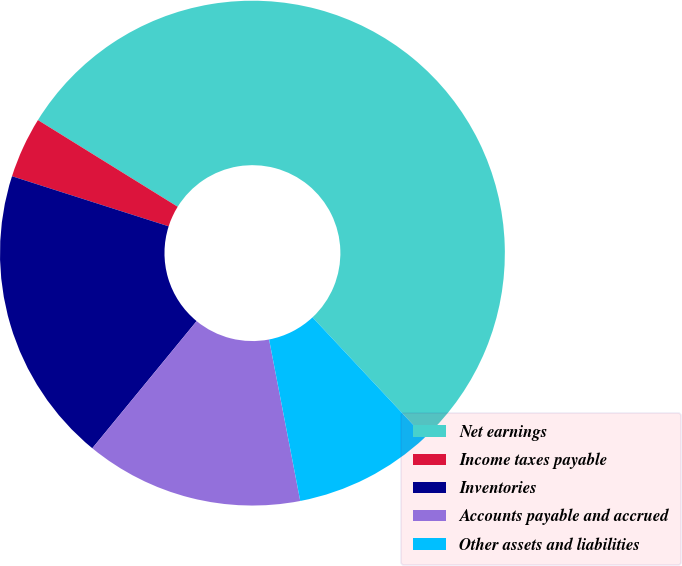Convert chart to OTSL. <chart><loc_0><loc_0><loc_500><loc_500><pie_chart><fcel>Net earnings<fcel>Income taxes payable<fcel>Inventories<fcel>Accounts payable and accrued<fcel>Other assets and liabilities<nl><fcel>54.19%<fcel>3.91%<fcel>18.99%<fcel>13.97%<fcel>8.94%<nl></chart> 